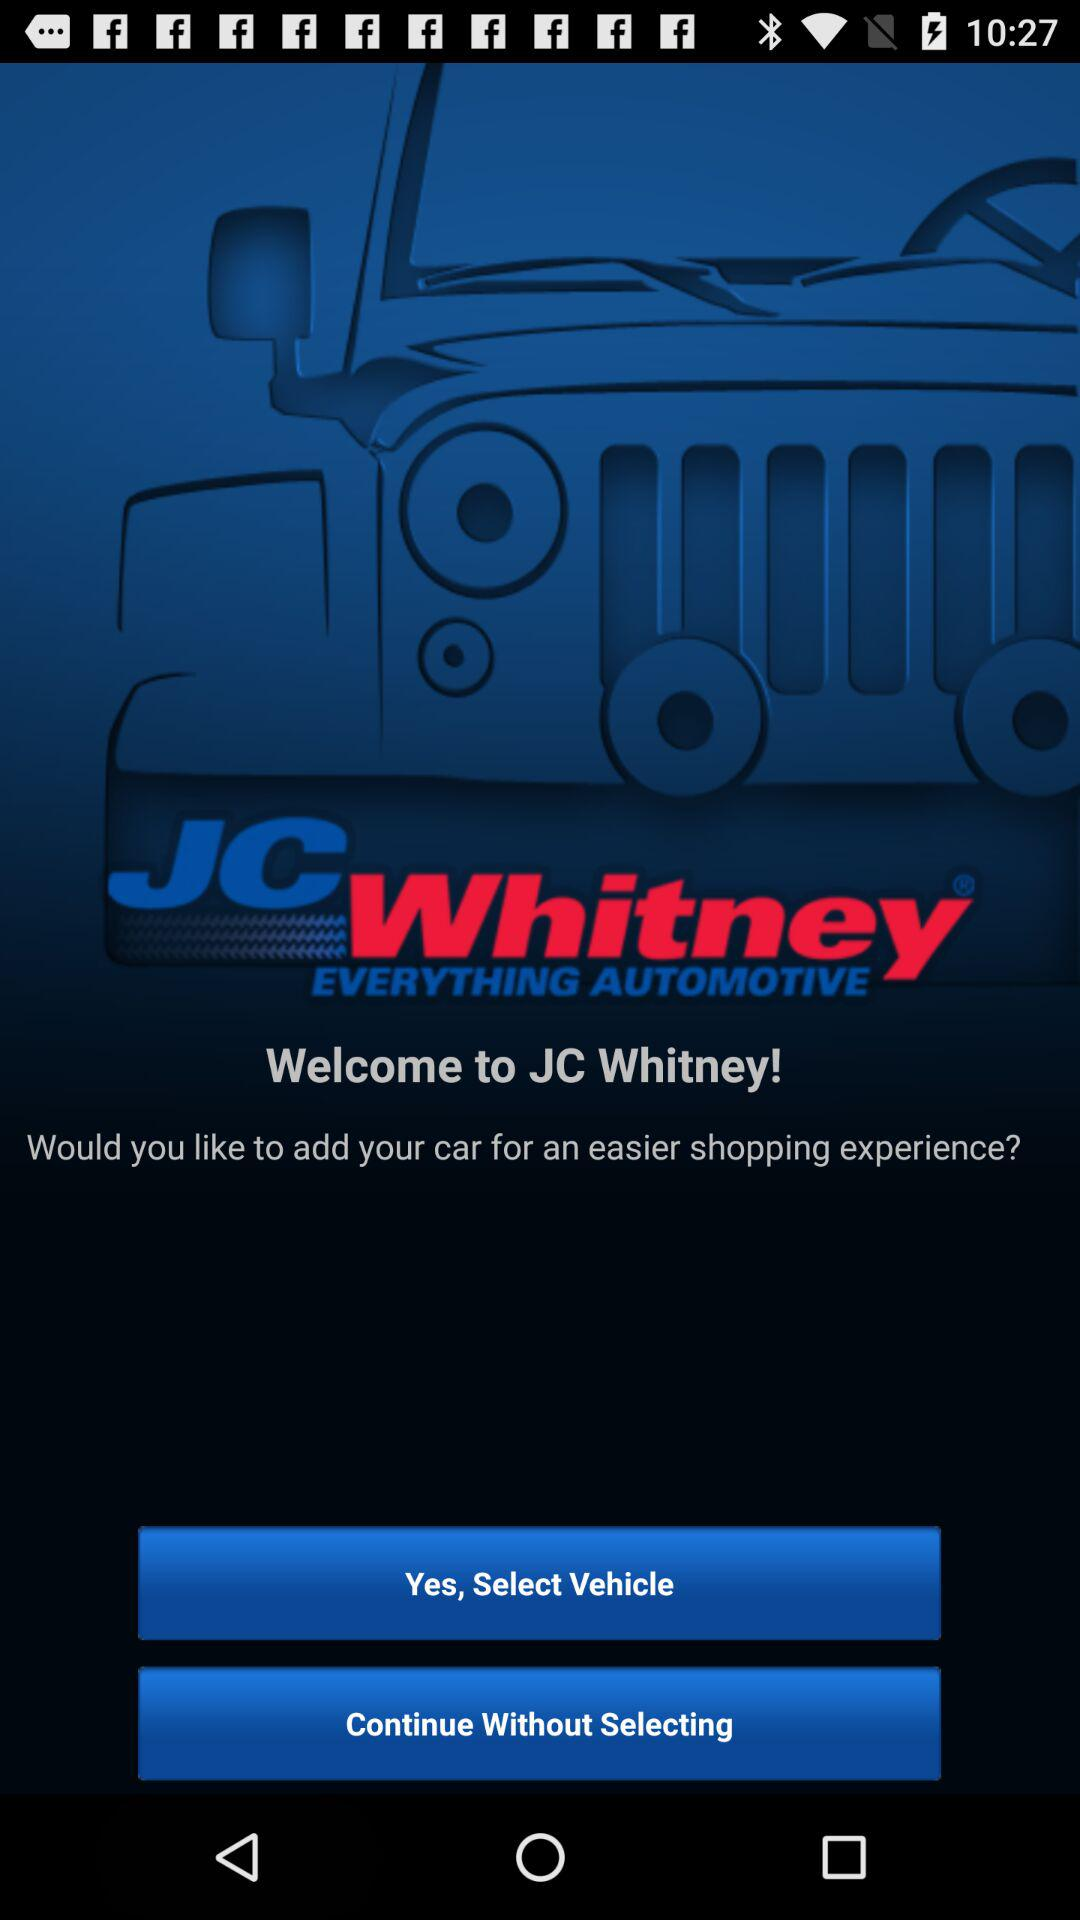What is the application name? The application name is "JC Whitney". 